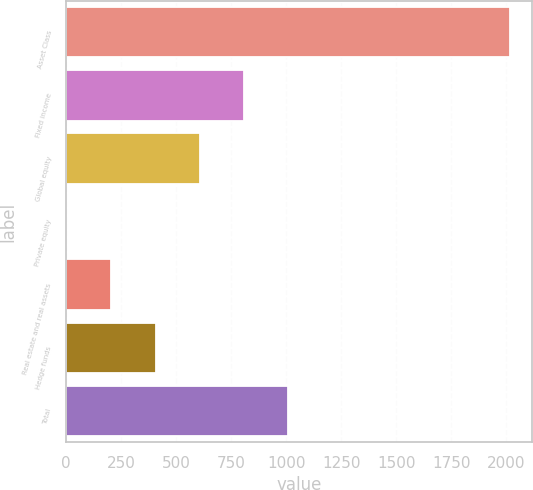Convert chart to OTSL. <chart><loc_0><loc_0><loc_500><loc_500><bar_chart><fcel>Asset Class<fcel>Fixed income<fcel>Global equity<fcel>Private equity<fcel>Real estate and real assets<fcel>Hedge funds<fcel>Total<nl><fcel>2017<fcel>809.8<fcel>608.6<fcel>5<fcel>206.2<fcel>407.4<fcel>1011<nl></chart> 